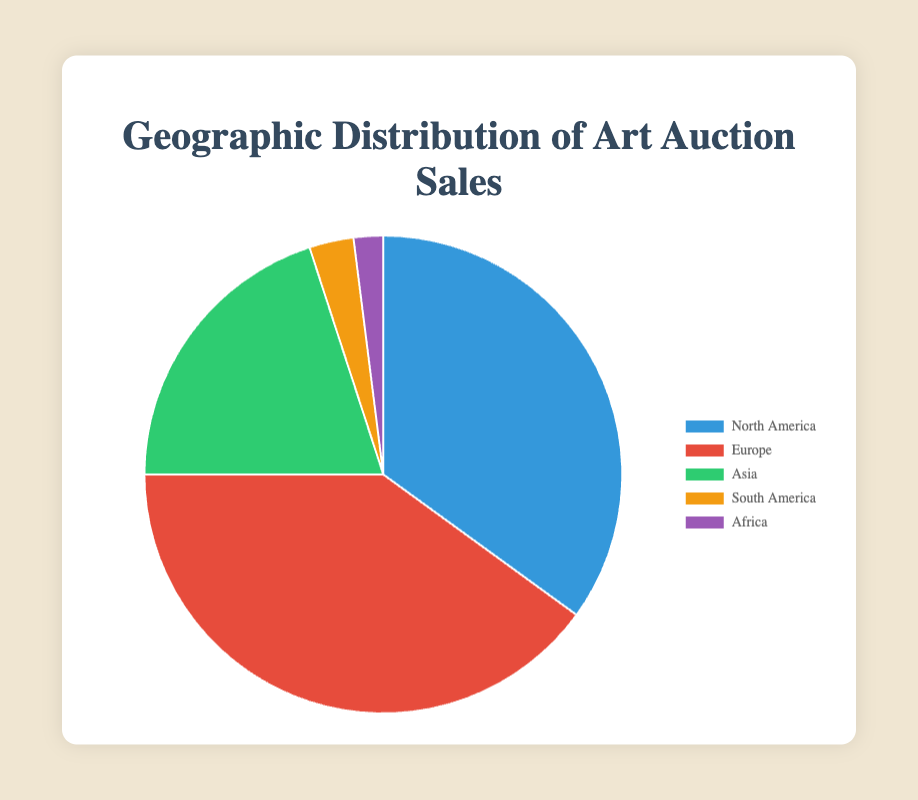What is the region with the highest percentage of art auction sales? Europe has the highest percentage value in the data set, which is 40%.
Answer: Europe What is the combined percentage of art auction sales in North America and Asia? North America's percentage is 35%, and Asia's is 20%. The sum of these percentages is 35% + 20% = 55%.
Answer: 55% Which two regions have the smallest percentages of art auction sales, and what is their combined percentage? South America has 3%, and Africa has 2%, making them the smallest. Their combined percentage is 3% + 2% = 5%.
Answer: South America and Africa, 5% How much larger is Europe’s percentage compared to Asia’s? Europe's percentage is 40%, and Asia's is 20%. The difference is 40% - 20% = 20%.
Answer: 20% What is the total percentage share of the top two regions? The top two regions are Europe (40%) and North America (35%). Summing these gives 40% + 35% = 75%.
Answer: 75% Which region is represented by the green color in the chart? The green color in the chart corresponds to Asia.
Answer: Asia Out of all the regions, how much more in percentage does North America have compared to South America and Africa combined? North America's percentage is 35%, while South America and Africa combined is 3% + 2% = 5%. The difference is 35% - 5% = 30%.
Answer: 30% Is the percentage of art auction sales in North America more than double that of Asia? North America has 35%, and Asia has 20%. Doubling Asia's 20% we get 40%, which is more than North America's 35%. Thus, North America's percentage is not more than double that of Asia.
Answer: No 